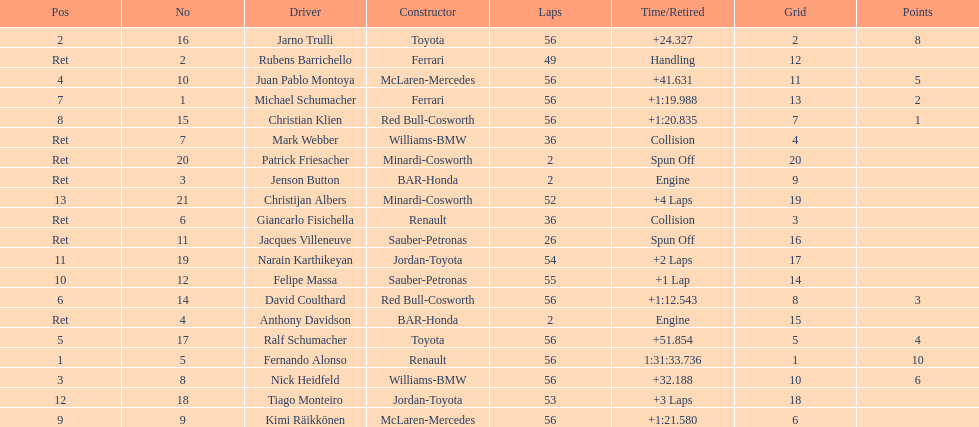How many germans finished in the top five? 2. 